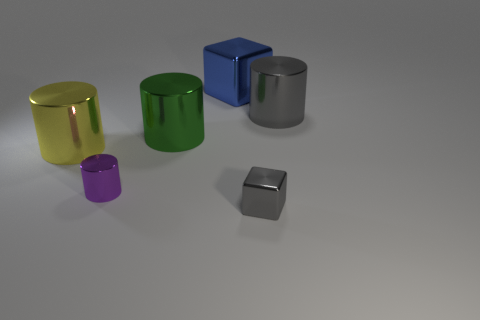Do the small metallic block and the metallic cylinder to the right of the big blue block have the same color?
Your answer should be very brief. Yes. There is a object that is behind the purple metal cylinder and on the right side of the big blue cube; how big is it?
Ensure brevity in your answer.  Large. There is a big blue object; are there any purple metal things on the right side of it?
Provide a succinct answer. No. Is there a tiny metal thing in front of the tiny metal object on the right side of the blue metallic cube?
Keep it short and to the point. No. Are there the same number of large blue shiny cubes in front of the big yellow metal cylinder and green metal things on the left side of the big green metal object?
Give a very brief answer. Yes. There is a small cylinder that is made of the same material as the small block; what color is it?
Offer a terse response. Purple. Are there any yellow things that have the same material as the big blue object?
Give a very brief answer. Yes. How many objects are either yellow metal things or big gray metallic cylinders?
Provide a short and direct response. 2. Does the green thing have the same material as the cylinder on the right side of the tiny gray metal block?
Ensure brevity in your answer.  Yes. There is a purple thing that is on the right side of the yellow cylinder; how big is it?
Give a very brief answer. Small. 